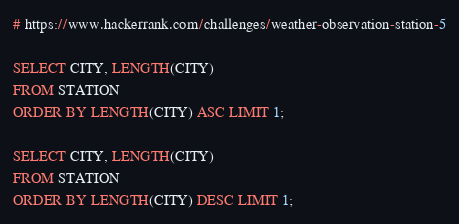<code> <loc_0><loc_0><loc_500><loc_500><_SQL_># https://www.hackerrank.com/challenges/weather-observation-station-5

SELECT CITY, LENGTH(CITY)
FROM STATION
ORDER BY LENGTH(CITY) ASC LIMIT 1;

SELECT CITY, LENGTH(CITY)
FROM STATION
ORDER BY LENGTH(CITY) DESC LIMIT 1;
</code> 